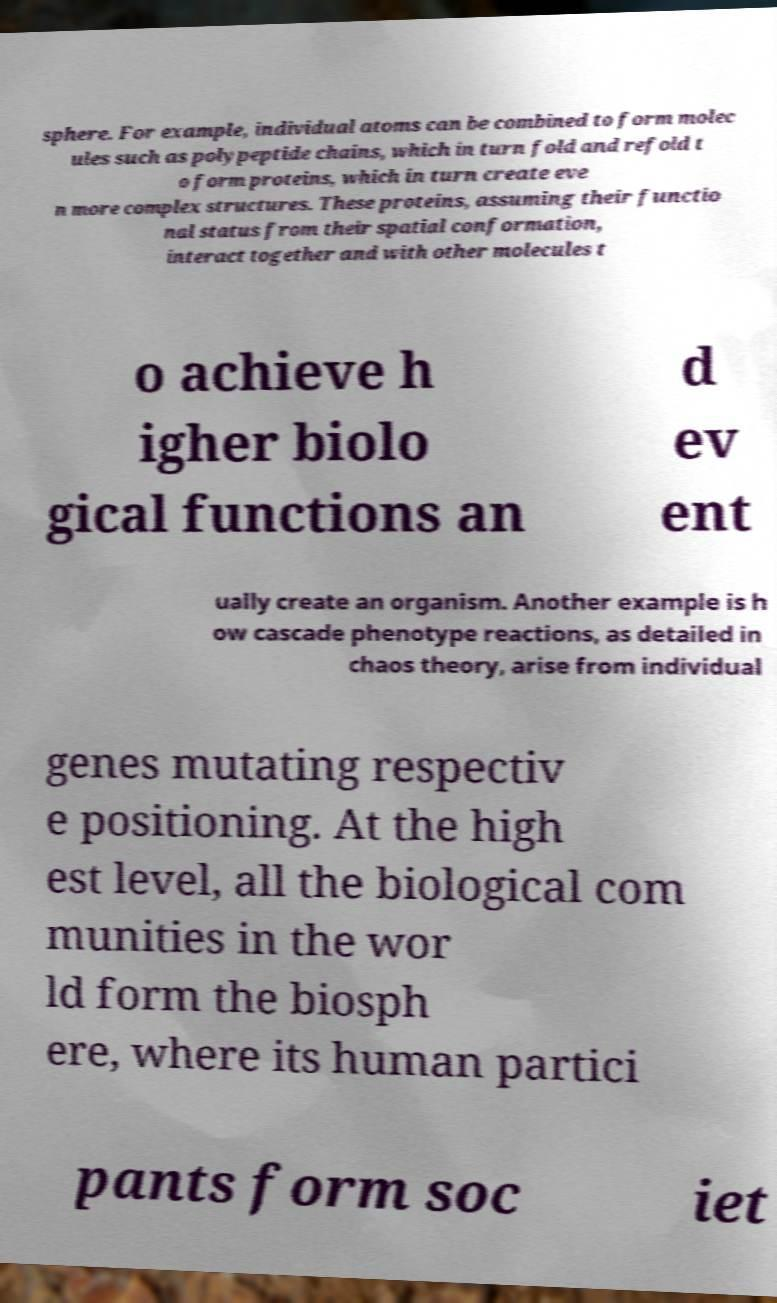Can you read and provide the text displayed in the image?This photo seems to have some interesting text. Can you extract and type it out for me? sphere. For example, individual atoms can be combined to form molec ules such as polypeptide chains, which in turn fold and refold t o form proteins, which in turn create eve n more complex structures. These proteins, assuming their functio nal status from their spatial conformation, interact together and with other molecules t o achieve h igher biolo gical functions an d ev ent ually create an organism. Another example is h ow cascade phenotype reactions, as detailed in chaos theory, arise from individual genes mutating respectiv e positioning. At the high est level, all the biological com munities in the wor ld form the biosph ere, where its human partici pants form soc iet 